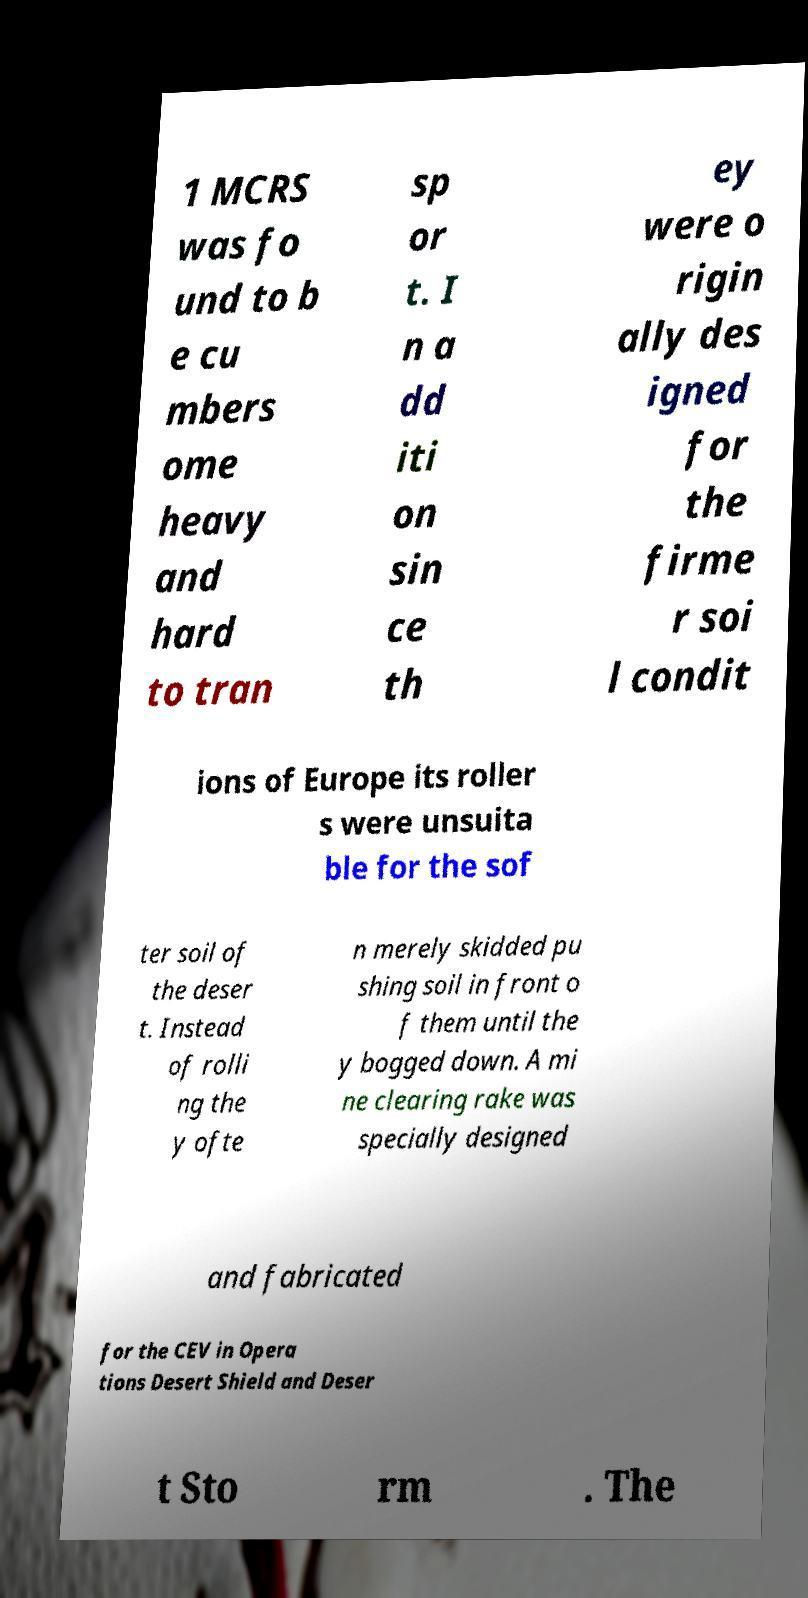Could you extract and type out the text from this image? 1 MCRS was fo und to b e cu mbers ome heavy and hard to tran sp or t. I n a dd iti on sin ce th ey were o rigin ally des igned for the firme r soi l condit ions of Europe its roller s were unsuita ble for the sof ter soil of the deser t. Instead of rolli ng the y ofte n merely skidded pu shing soil in front o f them until the y bogged down. A mi ne clearing rake was specially designed and fabricated for the CEV in Opera tions Desert Shield and Deser t Sto rm . The 